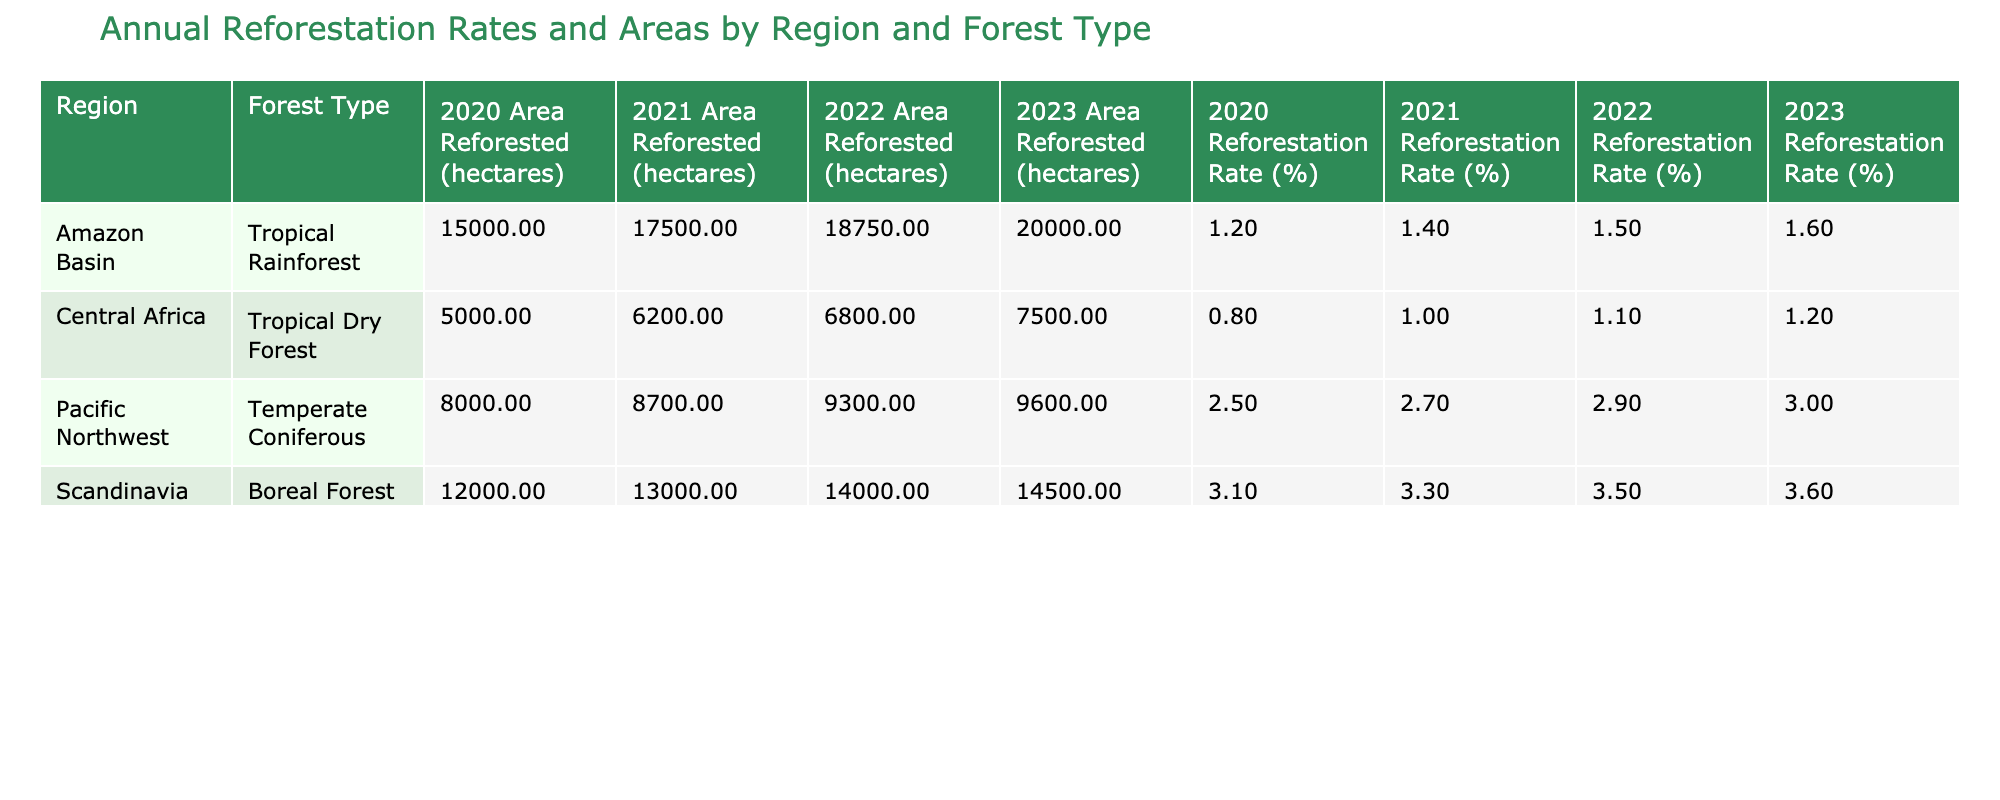What was the highest reforestation rate recorded in 2023? In 2023, the reforestation rates for each forest type in different regions are listed. Scanning through these, the highest rate recorded is 3.6% for the Boreal Forest in Scandinavia.
Answer: 3.6% Which region had the highest area reforested in 2021? By checking the area reforested in 2021 for each region, the values are: Amazon Basin - 17,500 hectares, Pacific Northwest - 8,700 hectares, Scandinavia - 13,000 hectares, and Central Africa - 6,200 hectares. The highest area reforested in 2021 was in the Amazon Basin.
Answer: Amazon Basin What is the average reforestation rate for Tropical Rainforest across the years provided? The reforestation rates for Tropical Rainforest are 1.2%, 1.4%, 1.5%, and 1.6% for the years 2020, 2021, 2022, and 2023 respectively. The sum is (1.2 + 1.4 + 1.5 + 1.6) = 5.7%. Dividing by the number of years (4), the average rate is 5.7 / 4 = 1.425%.
Answer: 1.425% Did the reforestation rate for Temperate Coniferous in the Pacific Northwest ever exceed 3%? Reviewing the rates for Temperate Coniferous in the Pacific Northwest, they are 2.5% (2020), 2.7% (2021), 2.9% (2022), and 3.0% (2023). None of these figures exceed 3%, except for the year 2023, when it precisely reached 3.0%. Therefore, the answer is yes.
Answer: Yes Which forest type had the most consistent reforestation rates across the provided years? Analyzing the data for each forest type, the reforestation rates for each year are as follows: Tropical Rainforest shows an incremental increase but varied rates; Temperate Coniferous rates are relatively stable but increasing; Boreal Forest shows an increasing trend too; Tropical Dry Forest has more fluctuation. A close examination reveals that Temperate Coniferous has the least variation, with rates steadily increasing.
Answer: Temperate Coniferous 